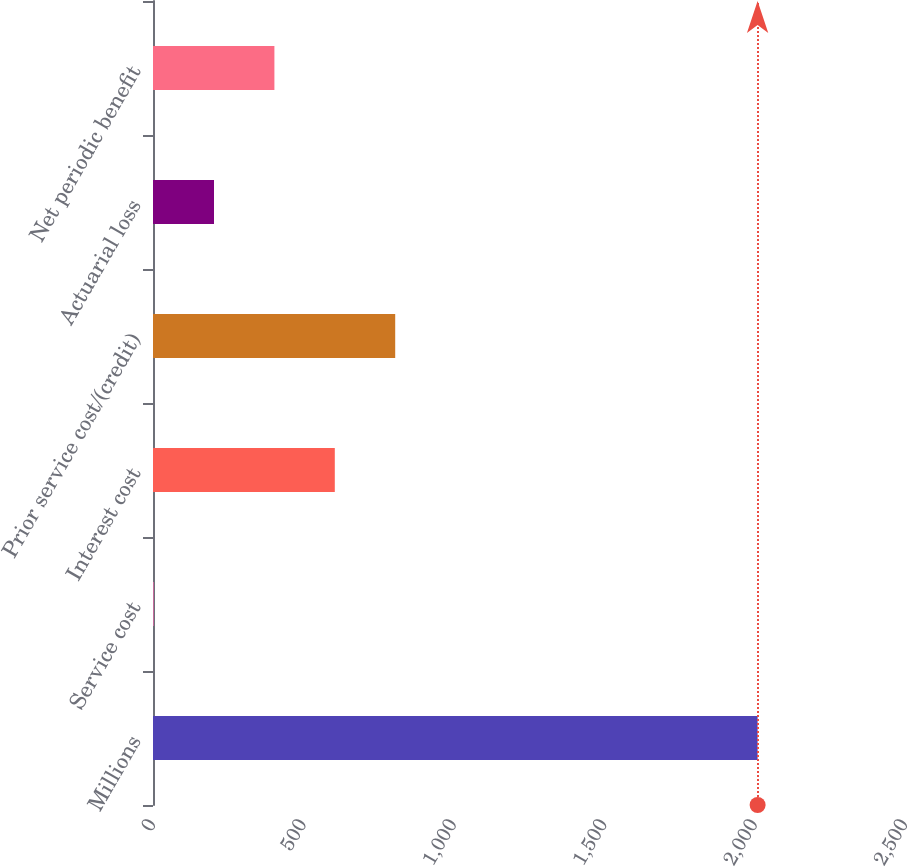<chart> <loc_0><loc_0><loc_500><loc_500><bar_chart><fcel>Millions<fcel>Service cost<fcel>Interest cost<fcel>Prior service cost/(credit)<fcel>Actuarial loss<fcel>Net periodic benefit<nl><fcel>2010<fcel>2<fcel>604.4<fcel>805.2<fcel>202.8<fcel>403.6<nl></chart> 